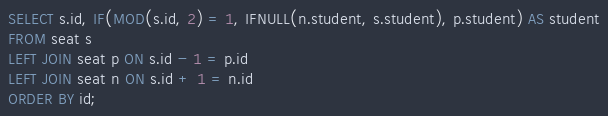Convert code to text. <code><loc_0><loc_0><loc_500><loc_500><_SQL_>SELECT s.id, IF(MOD(s.id, 2) = 1, IFNULL(n.student, s.student), p.student) AS student
FROM seat s
LEFT JOIN seat p ON s.id - 1 = p.id
LEFT JOIN seat n ON s.id + 1 = n.id
ORDER BY id;
</code> 